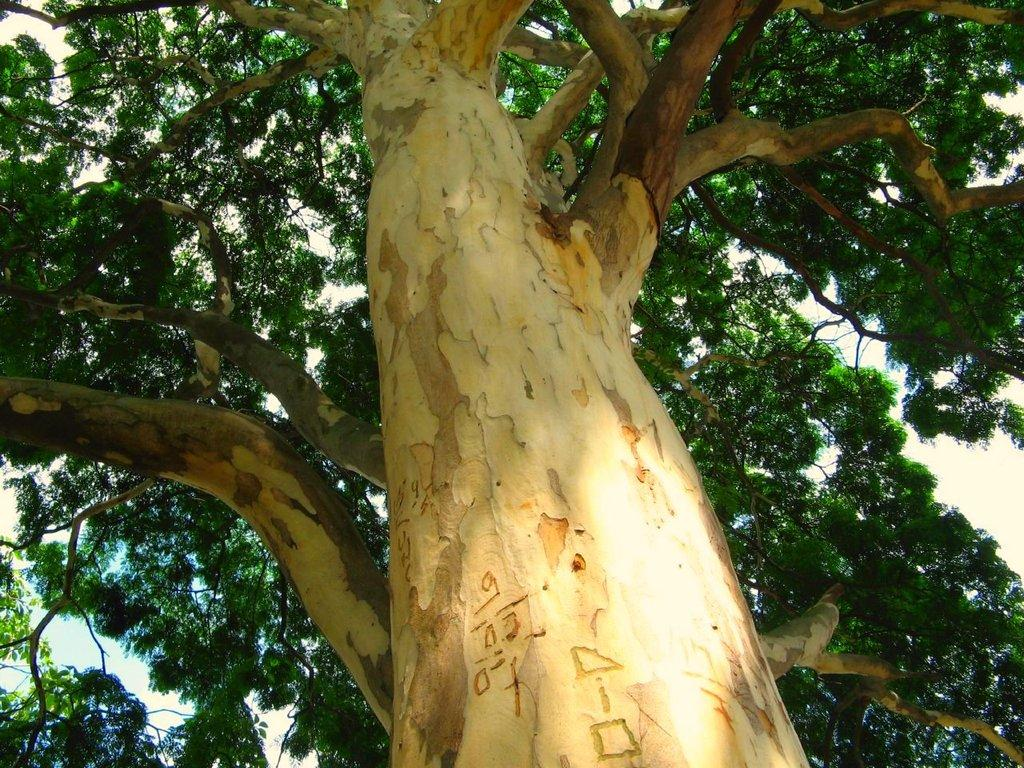What type of plant can be seen in the image? There is a tree in the image. What part of the tree is visible? There is a tree trunk visible in the image. What can be seen in the background of the image? The sky is visible in the background of the image. How many bells are hanging from the tree in the image? There are no bells present in the image; it only features a tree and its trunk. What type of animals can be seen interacting with the tree in the image? There are no animals present in the image; it only features a tree and its trunk. 